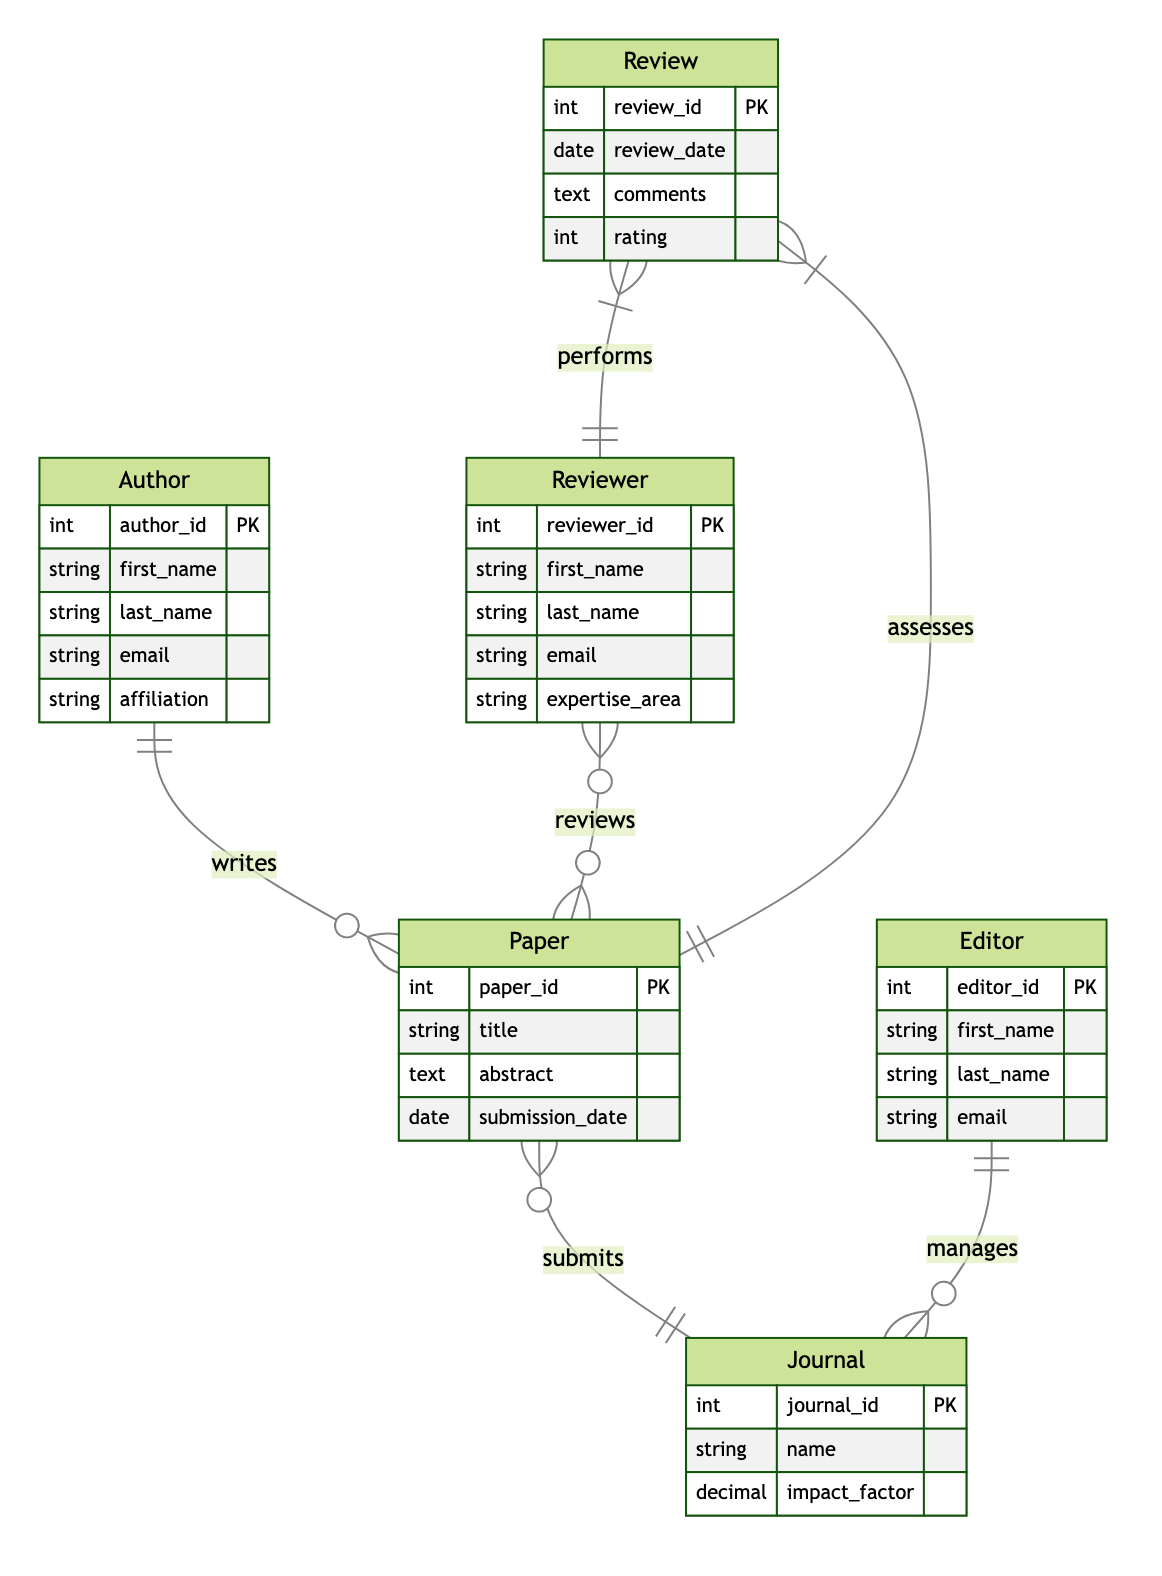What is the primary key of the Author entity? The primary key of the Author entity is denoted in the diagram with "PK" next to the author_id attribute, indicating it uniquely identifies each Author.
Answer: author_id How many entities are present in the diagram? By counting the distinct entities listed (Author, Paper, Reviewer, Review, Editor, Journal), we find that there are six different entities represented in the diagram.
Answer: six What type of relationship exists between Paper and Journal? The diagram specifies a many-to-one relationship between Paper and Journal, indicated by the notation showing multiple Paper entities can submit to a single Journal.
Answer: many-to-one Which entity manages the Journal? The Editor entity is indicated to have a managing relationship with the Journal, as shown by the line connecting them with a "1-to-many" relationship notation in the diagram.
Answer: Editor What attributes are associated with the Reviewer entity? The attributes associated with the Reviewer entity, as shown in the diagram, are reviewer_id, first_name, last_name, email, and expertise_area.
Answer: reviewer_id, first_name, last_name, email, expertise_area How many possible reviews can be linked to a Paper? The relationship between Reviewer and Paper shows a many-to-many structure; therefore, each Paper can have multiple Reviews attached to it depending on how many Reviewers are involved.
Answer: many What does the Review entity assess? The Review entity is illustrated to assess the Paper, establishing a connection in the diagram that indicates a direct relationship of evaluation between Review and Paper.
Answer: Paper Which entity is responsible for performing the Review? The diagram indicates that the Reviewer entity is responsible for performing reviews, as shown by the line connecting Reviewer to Review with a "1-to-many" relationship notation.
Answer: Reviewer 